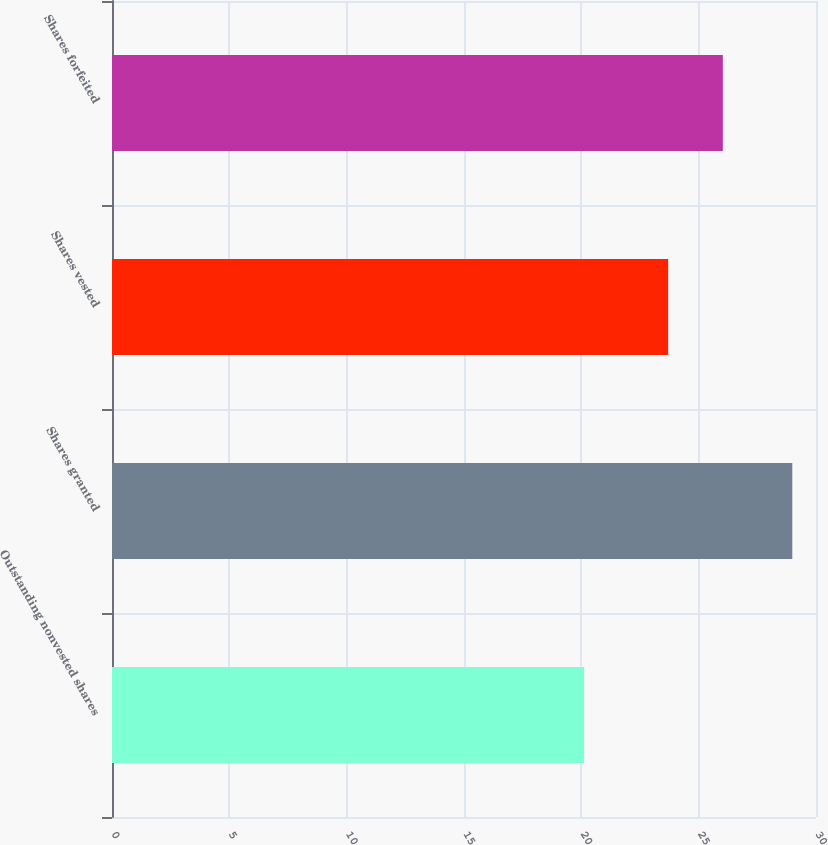<chart> <loc_0><loc_0><loc_500><loc_500><bar_chart><fcel>Outstanding nonvested shares<fcel>Shares granted<fcel>Shares vested<fcel>Shares forfeited<nl><fcel>20.12<fcel>28.99<fcel>23.7<fcel>26.03<nl></chart> 